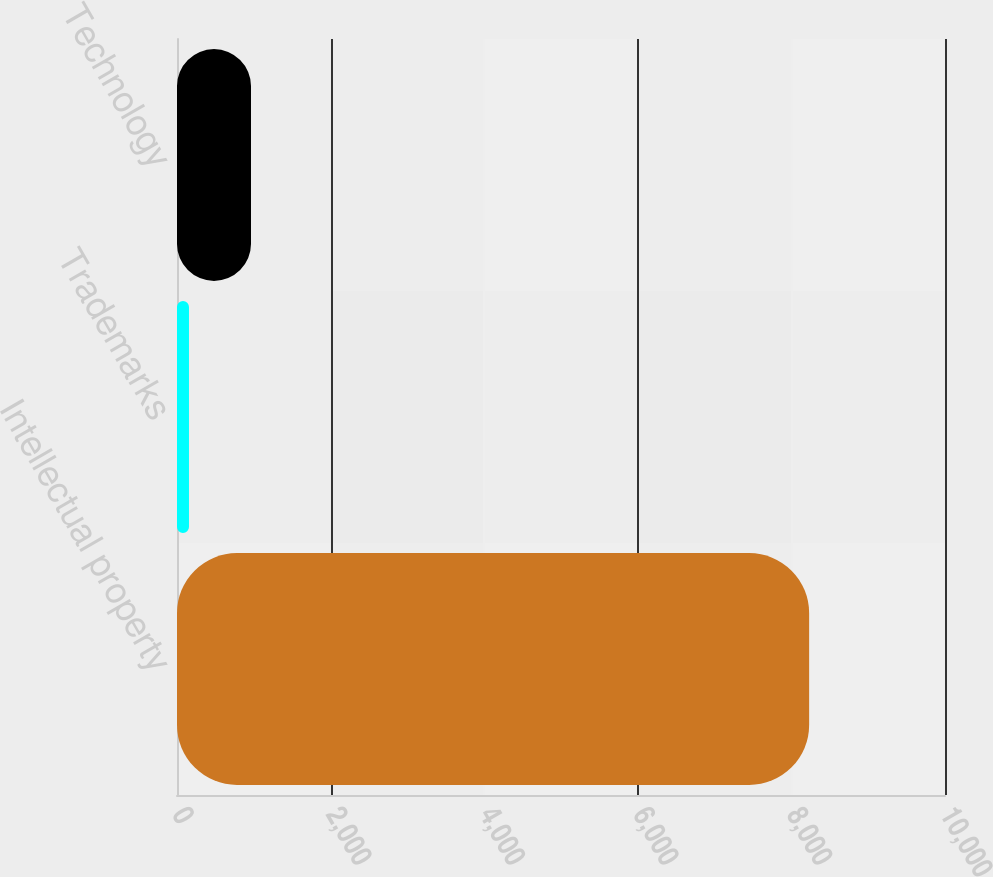Convert chart. <chart><loc_0><loc_0><loc_500><loc_500><bar_chart><fcel>Intellectual property<fcel>Trademarks<fcel>Technology<nl><fcel>8231<fcel>156<fcel>963.5<nl></chart> 